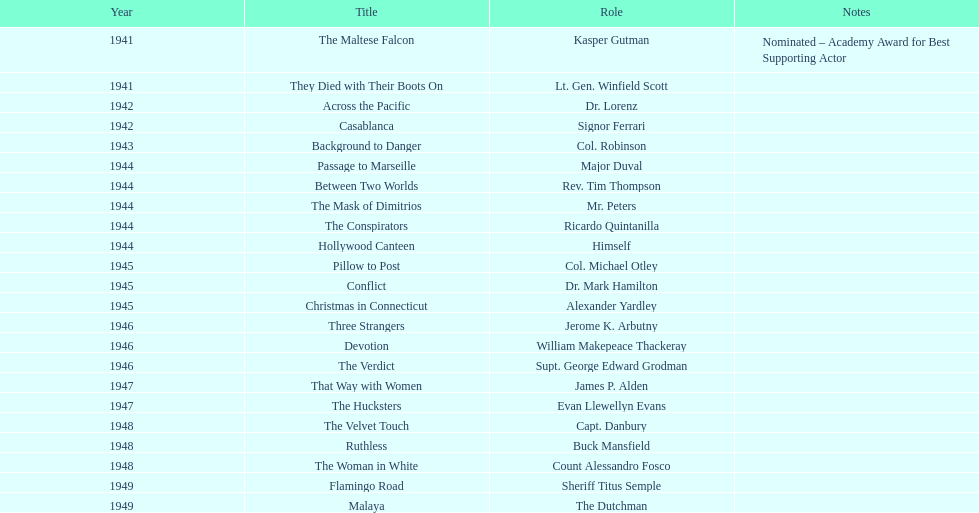How extended was sydney greenstreet's acting occupation? 9 years. Would you be able to parse every entry in this table? {'header': ['Year', 'Title', 'Role', 'Notes'], 'rows': [['1941', 'The Maltese Falcon', 'Kasper Gutman', 'Nominated – Academy Award for Best Supporting Actor'], ['1941', 'They Died with Their Boots On', 'Lt. Gen. Winfield Scott', ''], ['1942', 'Across the Pacific', 'Dr. Lorenz', ''], ['1942', 'Casablanca', 'Signor Ferrari', ''], ['1943', 'Background to Danger', 'Col. Robinson', ''], ['1944', 'Passage to Marseille', 'Major Duval', ''], ['1944', 'Between Two Worlds', 'Rev. Tim Thompson', ''], ['1944', 'The Mask of Dimitrios', 'Mr. Peters', ''], ['1944', 'The Conspirators', 'Ricardo Quintanilla', ''], ['1944', 'Hollywood Canteen', 'Himself', ''], ['1945', 'Pillow to Post', 'Col. Michael Otley', ''], ['1945', 'Conflict', 'Dr. Mark Hamilton', ''], ['1945', 'Christmas in Connecticut', 'Alexander Yardley', ''], ['1946', 'Three Strangers', 'Jerome K. Arbutny', ''], ['1946', 'Devotion', 'William Makepeace Thackeray', ''], ['1946', 'The Verdict', 'Supt. George Edward Grodman', ''], ['1947', 'That Way with Women', 'James P. Alden', ''], ['1947', 'The Hucksters', 'Evan Llewellyn Evans', ''], ['1948', 'The Velvet Touch', 'Capt. Danbury', ''], ['1948', 'Ruthless', 'Buck Mansfield', ''], ['1948', 'The Woman in White', 'Count Alessandro Fosco', ''], ['1949', 'Flamingo Road', 'Sheriff Titus Semple', ''], ['1949', 'Malaya', 'The Dutchman', '']]} 